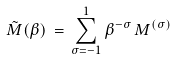Convert formula to latex. <formula><loc_0><loc_0><loc_500><loc_500>\tilde { M } ( \beta ) \, = \, \sum _ { \sigma = - 1 } ^ { 1 } \beta ^ { - \sigma } \, M ^ { ( \sigma ) }</formula> 